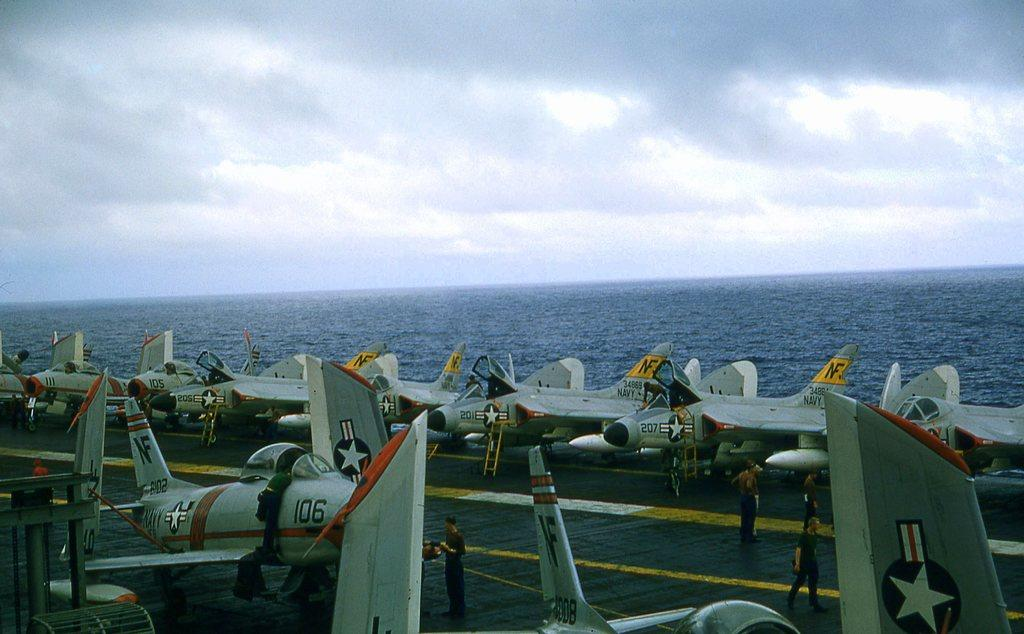What type of vehicles are on the ship in the image? There are jet planes on a ship in the image. What natural feature can be seen in the image? There is an ocean visible in the image. What else is visible in the image besides the ship and ocean? The sky is visible in the image. What can be observed in the sky? Clouds are present in the sky. What type of punishment is being given to the shirt in the image? There is no shirt present in the image, and therefore no punishment can be observed. 